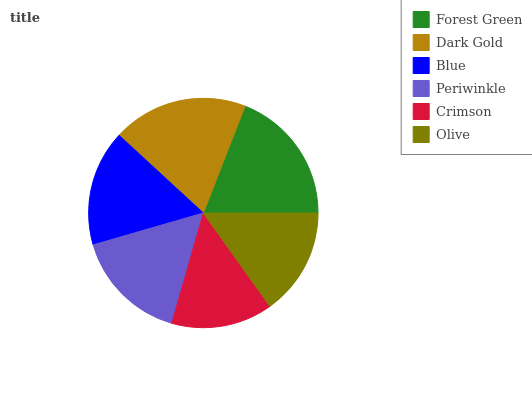Is Crimson the minimum?
Answer yes or no. Yes. Is Forest Green the maximum?
Answer yes or no. Yes. Is Dark Gold the minimum?
Answer yes or no. No. Is Dark Gold the maximum?
Answer yes or no. No. Is Forest Green greater than Dark Gold?
Answer yes or no. Yes. Is Dark Gold less than Forest Green?
Answer yes or no. Yes. Is Dark Gold greater than Forest Green?
Answer yes or no. No. Is Forest Green less than Dark Gold?
Answer yes or no. No. Is Blue the high median?
Answer yes or no. Yes. Is Periwinkle the low median?
Answer yes or no. Yes. Is Periwinkle the high median?
Answer yes or no. No. Is Blue the low median?
Answer yes or no. No. 